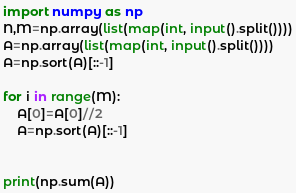Convert code to text. <code><loc_0><loc_0><loc_500><loc_500><_Python_>import numpy as np
N,M=np.array(list(map(int, input().split())))
A=np.array(list(map(int, input().split())))
A=np.sort(A)[::-1]

for i in range(M):
    A[0]=A[0]//2
    A=np.sort(A)[::-1]


print(np.sum(A))</code> 